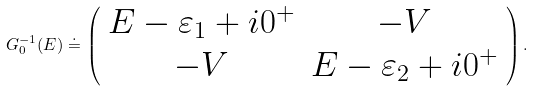Convert formula to latex. <formula><loc_0><loc_0><loc_500><loc_500>G _ { 0 } ^ { - 1 } ( E ) \doteq \left ( \begin{array} { c c } E - \varepsilon _ { 1 } + i 0 ^ { + } & - V \\ - V & E - \varepsilon _ { 2 } + i 0 ^ { + } \end{array} \right ) .</formula> 